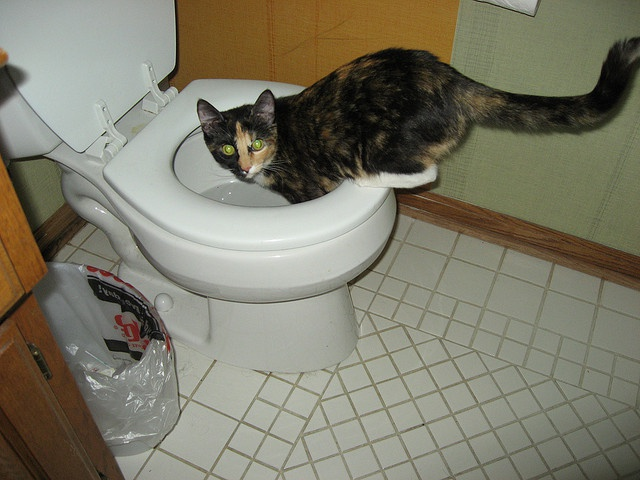Describe the objects in this image and their specific colors. I can see toilet in darkgreen, darkgray, lightgray, and gray tones and cat in gray, black, and darkgreen tones in this image. 